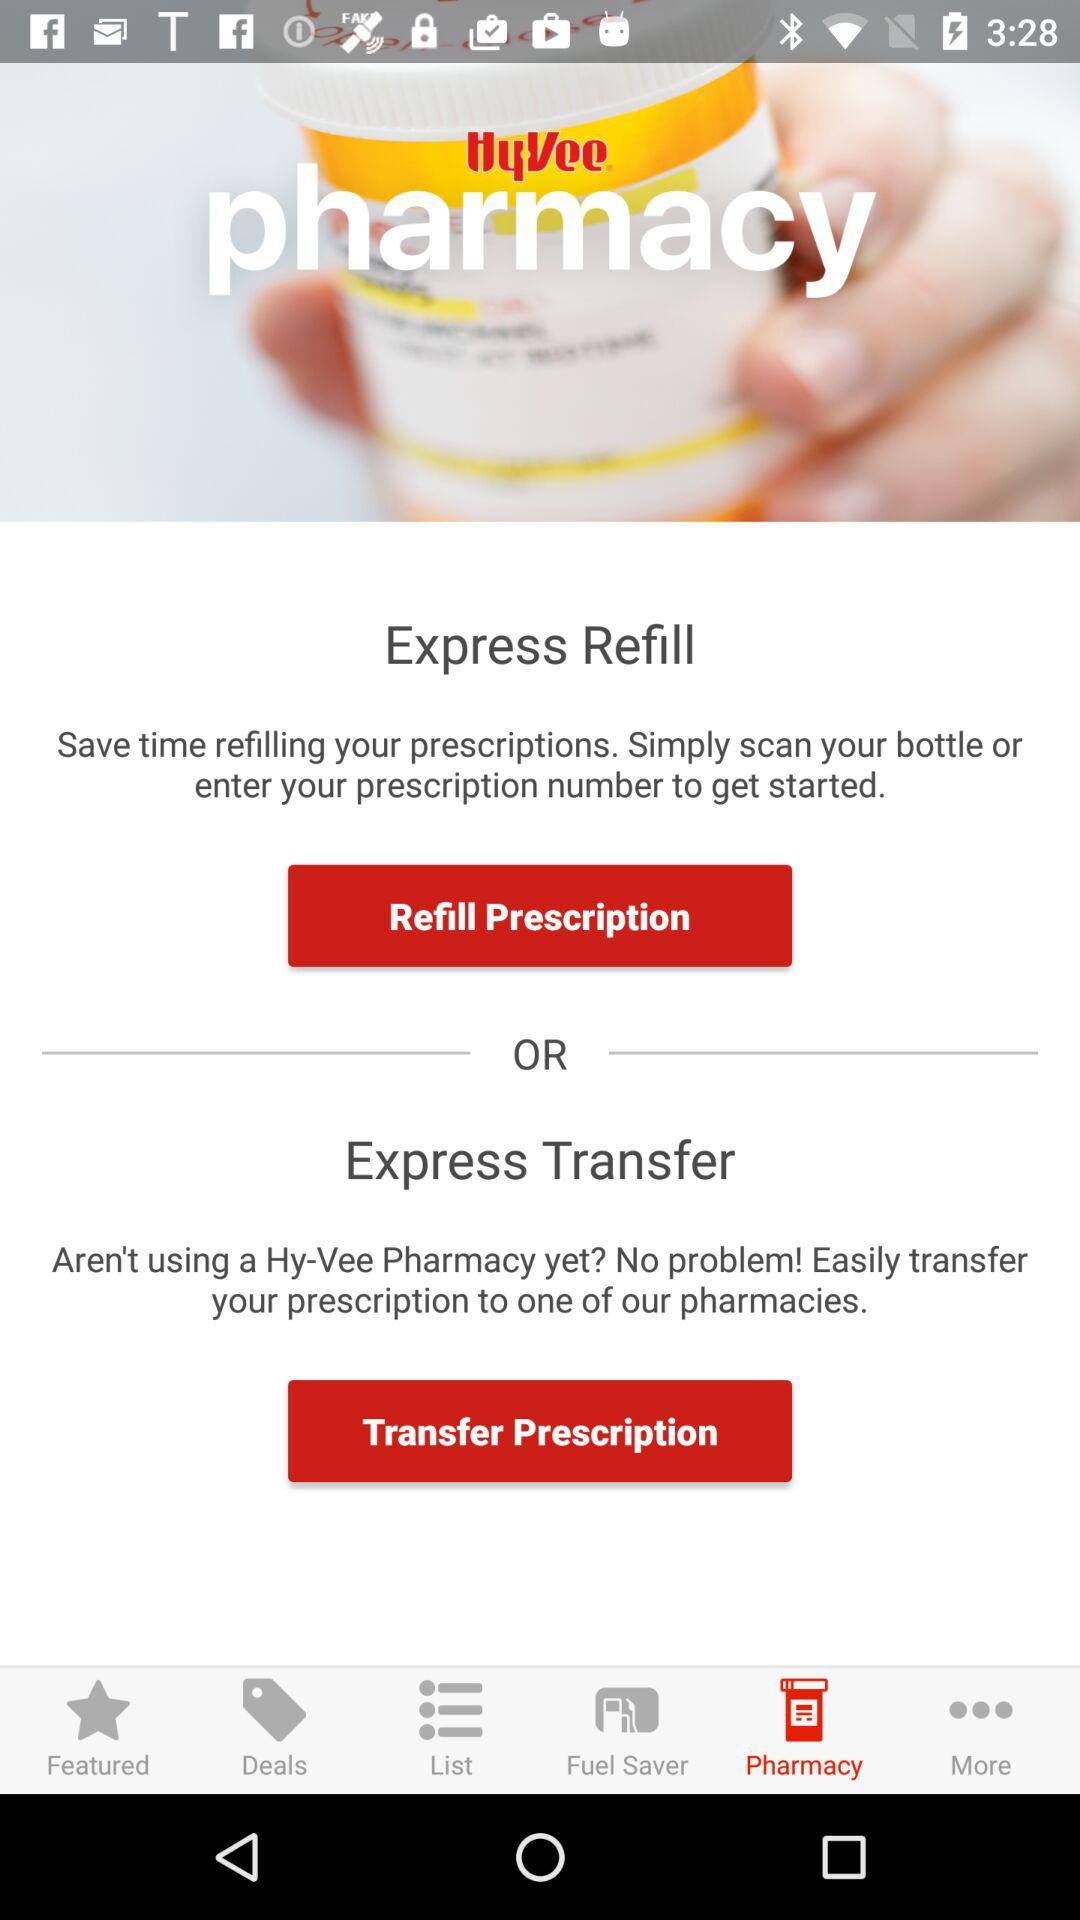Which option is selected? The selected option is "Pharmacy". 